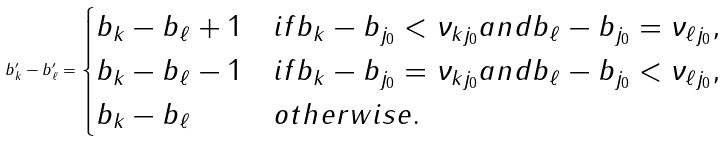<formula> <loc_0><loc_0><loc_500><loc_500>b ^ { \prime } _ { k } - b ^ { \prime } _ { \ell } = \begin{cases} b _ { k } - b _ { \ell } + 1 & i f b _ { k } - b _ { j _ { 0 } } < \nu _ { k j _ { 0 } } a n d b _ { \ell } - b _ { j _ { 0 } } = \nu _ { \ell j _ { 0 } } , \\ b _ { k } - b _ { \ell } - 1 & i f b _ { k } - b _ { j _ { 0 } } = \nu _ { k j _ { 0 } } a n d b _ { \ell } - b _ { j _ { 0 } } < \nu _ { \ell j _ { 0 } } , \\ b _ { k } - b _ { \ell } & o t h e r w i s e . \end{cases}</formula> 